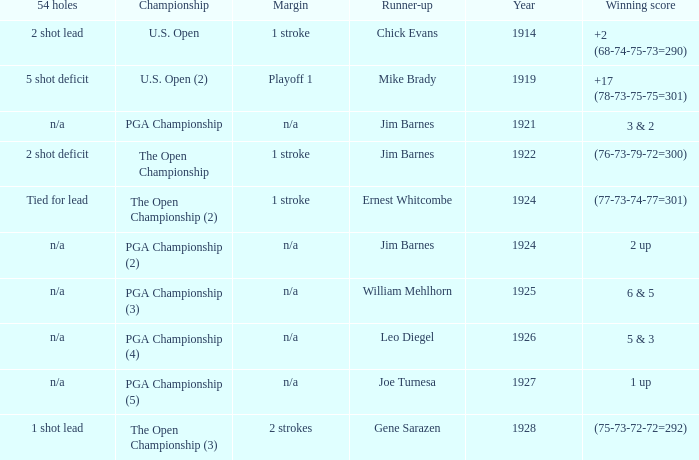WHAT WAS THE WINNING SCORE IN YEAR 1922? (76-73-79-72=300). 